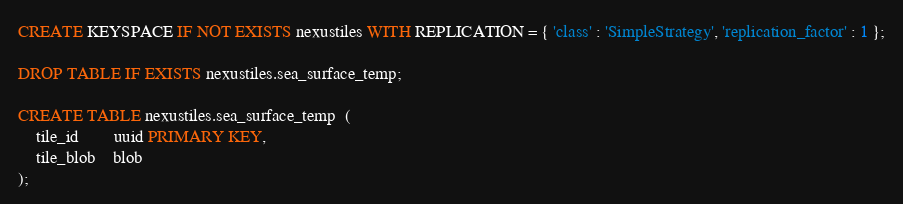Convert code to text. <code><loc_0><loc_0><loc_500><loc_500><_SQL_>CREATE KEYSPACE IF NOT EXISTS nexustiles WITH REPLICATION = { 'class' : 'SimpleStrategy', 'replication_factor' : 1 };

DROP TABLE IF EXISTS nexustiles.sea_surface_temp;

CREATE TABLE nexustiles.sea_surface_temp  (
	tile_id    	uuid PRIMARY KEY,
	tile_blob  	blob
);
</code> 